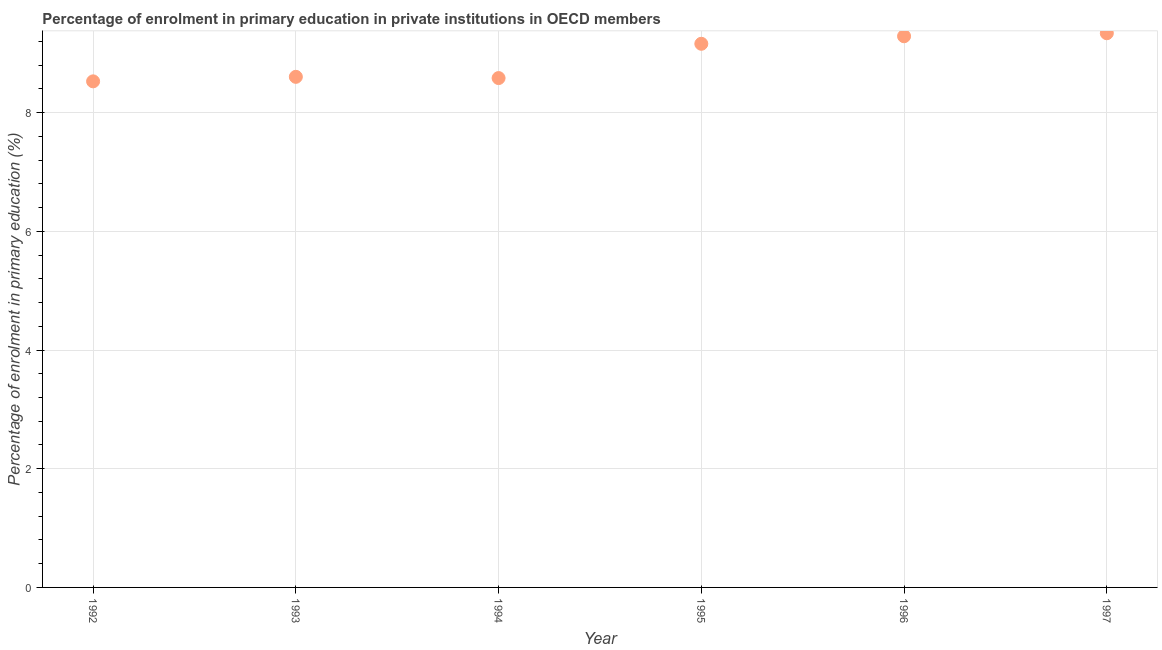What is the enrolment percentage in primary education in 1993?
Provide a succinct answer. 8.6. Across all years, what is the maximum enrolment percentage in primary education?
Give a very brief answer. 9.34. Across all years, what is the minimum enrolment percentage in primary education?
Offer a very short reply. 8.53. In which year was the enrolment percentage in primary education maximum?
Offer a terse response. 1997. What is the sum of the enrolment percentage in primary education?
Keep it short and to the point. 53.5. What is the difference between the enrolment percentage in primary education in 1993 and 1994?
Provide a short and direct response. 0.02. What is the average enrolment percentage in primary education per year?
Provide a short and direct response. 8.92. What is the median enrolment percentage in primary education?
Give a very brief answer. 8.88. In how many years, is the enrolment percentage in primary education greater than 0.8 %?
Your response must be concise. 6. What is the ratio of the enrolment percentage in primary education in 1994 to that in 1996?
Make the answer very short. 0.92. Is the enrolment percentage in primary education in 1994 less than that in 1995?
Provide a short and direct response. Yes. Is the difference between the enrolment percentage in primary education in 1992 and 1994 greater than the difference between any two years?
Keep it short and to the point. No. What is the difference between the highest and the second highest enrolment percentage in primary education?
Your answer should be very brief. 0.05. Is the sum of the enrolment percentage in primary education in 1993 and 1994 greater than the maximum enrolment percentage in primary education across all years?
Your response must be concise. Yes. What is the difference between the highest and the lowest enrolment percentage in primary education?
Your response must be concise. 0.81. Does the enrolment percentage in primary education monotonically increase over the years?
Your answer should be very brief. No. How many years are there in the graph?
Your answer should be compact. 6. What is the difference between two consecutive major ticks on the Y-axis?
Your answer should be very brief. 2. Are the values on the major ticks of Y-axis written in scientific E-notation?
Offer a very short reply. No. What is the title of the graph?
Your answer should be very brief. Percentage of enrolment in primary education in private institutions in OECD members. What is the label or title of the X-axis?
Ensure brevity in your answer.  Year. What is the label or title of the Y-axis?
Offer a very short reply. Percentage of enrolment in primary education (%). What is the Percentage of enrolment in primary education (%) in 1992?
Your answer should be compact. 8.53. What is the Percentage of enrolment in primary education (%) in 1993?
Offer a very short reply. 8.6. What is the Percentage of enrolment in primary education (%) in 1994?
Offer a very short reply. 8.58. What is the Percentage of enrolment in primary education (%) in 1995?
Offer a terse response. 9.16. What is the Percentage of enrolment in primary education (%) in 1996?
Ensure brevity in your answer.  9.29. What is the Percentage of enrolment in primary education (%) in 1997?
Offer a terse response. 9.34. What is the difference between the Percentage of enrolment in primary education (%) in 1992 and 1993?
Give a very brief answer. -0.08. What is the difference between the Percentage of enrolment in primary education (%) in 1992 and 1994?
Your answer should be compact. -0.06. What is the difference between the Percentage of enrolment in primary education (%) in 1992 and 1995?
Provide a succinct answer. -0.63. What is the difference between the Percentage of enrolment in primary education (%) in 1992 and 1996?
Offer a terse response. -0.76. What is the difference between the Percentage of enrolment in primary education (%) in 1992 and 1997?
Provide a short and direct response. -0.81. What is the difference between the Percentage of enrolment in primary education (%) in 1993 and 1994?
Your answer should be very brief. 0.02. What is the difference between the Percentage of enrolment in primary education (%) in 1993 and 1995?
Make the answer very short. -0.56. What is the difference between the Percentage of enrolment in primary education (%) in 1993 and 1996?
Offer a terse response. -0.68. What is the difference between the Percentage of enrolment in primary education (%) in 1993 and 1997?
Your answer should be compact. -0.73. What is the difference between the Percentage of enrolment in primary education (%) in 1994 and 1995?
Ensure brevity in your answer.  -0.58. What is the difference between the Percentage of enrolment in primary education (%) in 1994 and 1996?
Provide a short and direct response. -0.7. What is the difference between the Percentage of enrolment in primary education (%) in 1994 and 1997?
Ensure brevity in your answer.  -0.76. What is the difference between the Percentage of enrolment in primary education (%) in 1995 and 1996?
Your response must be concise. -0.13. What is the difference between the Percentage of enrolment in primary education (%) in 1995 and 1997?
Provide a succinct answer. -0.18. What is the difference between the Percentage of enrolment in primary education (%) in 1996 and 1997?
Provide a succinct answer. -0.05. What is the ratio of the Percentage of enrolment in primary education (%) in 1992 to that in 1994?
Your answer should be compact. 0.99. What is the ratio of the Percentage of enrolment in primary education (%) in 1992 to that in 1996?
Your answer should be very brief. 0.92. What is the ratio of the Percentage of enrolment in primary education (%) in 1993 to that in 1994?
Make the answer very short. 1. What is the ratio of the Percentage of enrolment in primary education (%) in 1993 to that in 1995?
Your response must be concise. 0.94. What is the ratio of the Percentage of enrolment in primary education (%) in 1993 to that in 1996?
Keep it short and to the point. 0.93. What is the ratio of the Percentage of enrolment in primary education (%) in 1993 to that in 1997?
Keep it short and to the point. 0.92. What is the ratio of the Percentage of enrolment in primary education (%) in 1994 to that in 1995?
Keep it short and to the point. 0.94. What is the ratio of the Percentage of enrolment in primary education (%) in 1994 to that in 1996?
Offer a terse response. 0.92. What is the ratio of the Percentage of enrolment in primary education (%) in 1994 to that in 1997?
Offer a terse response. 0.92. What is the ratio of the Percentage of enrolment in primary education (%) in 1995 to that in 1996?
Ensure brevity in your answer.  0.99. What is the ratio of the Percentage of enrolment in primary education (%) in 1995 to that in 1997?
Offer a very short reply. 0.98. What is the ratio of the Percentage of enrolment in primary education (%) in 1996 to that in 1997?
Offer a terse response. 0.99. 